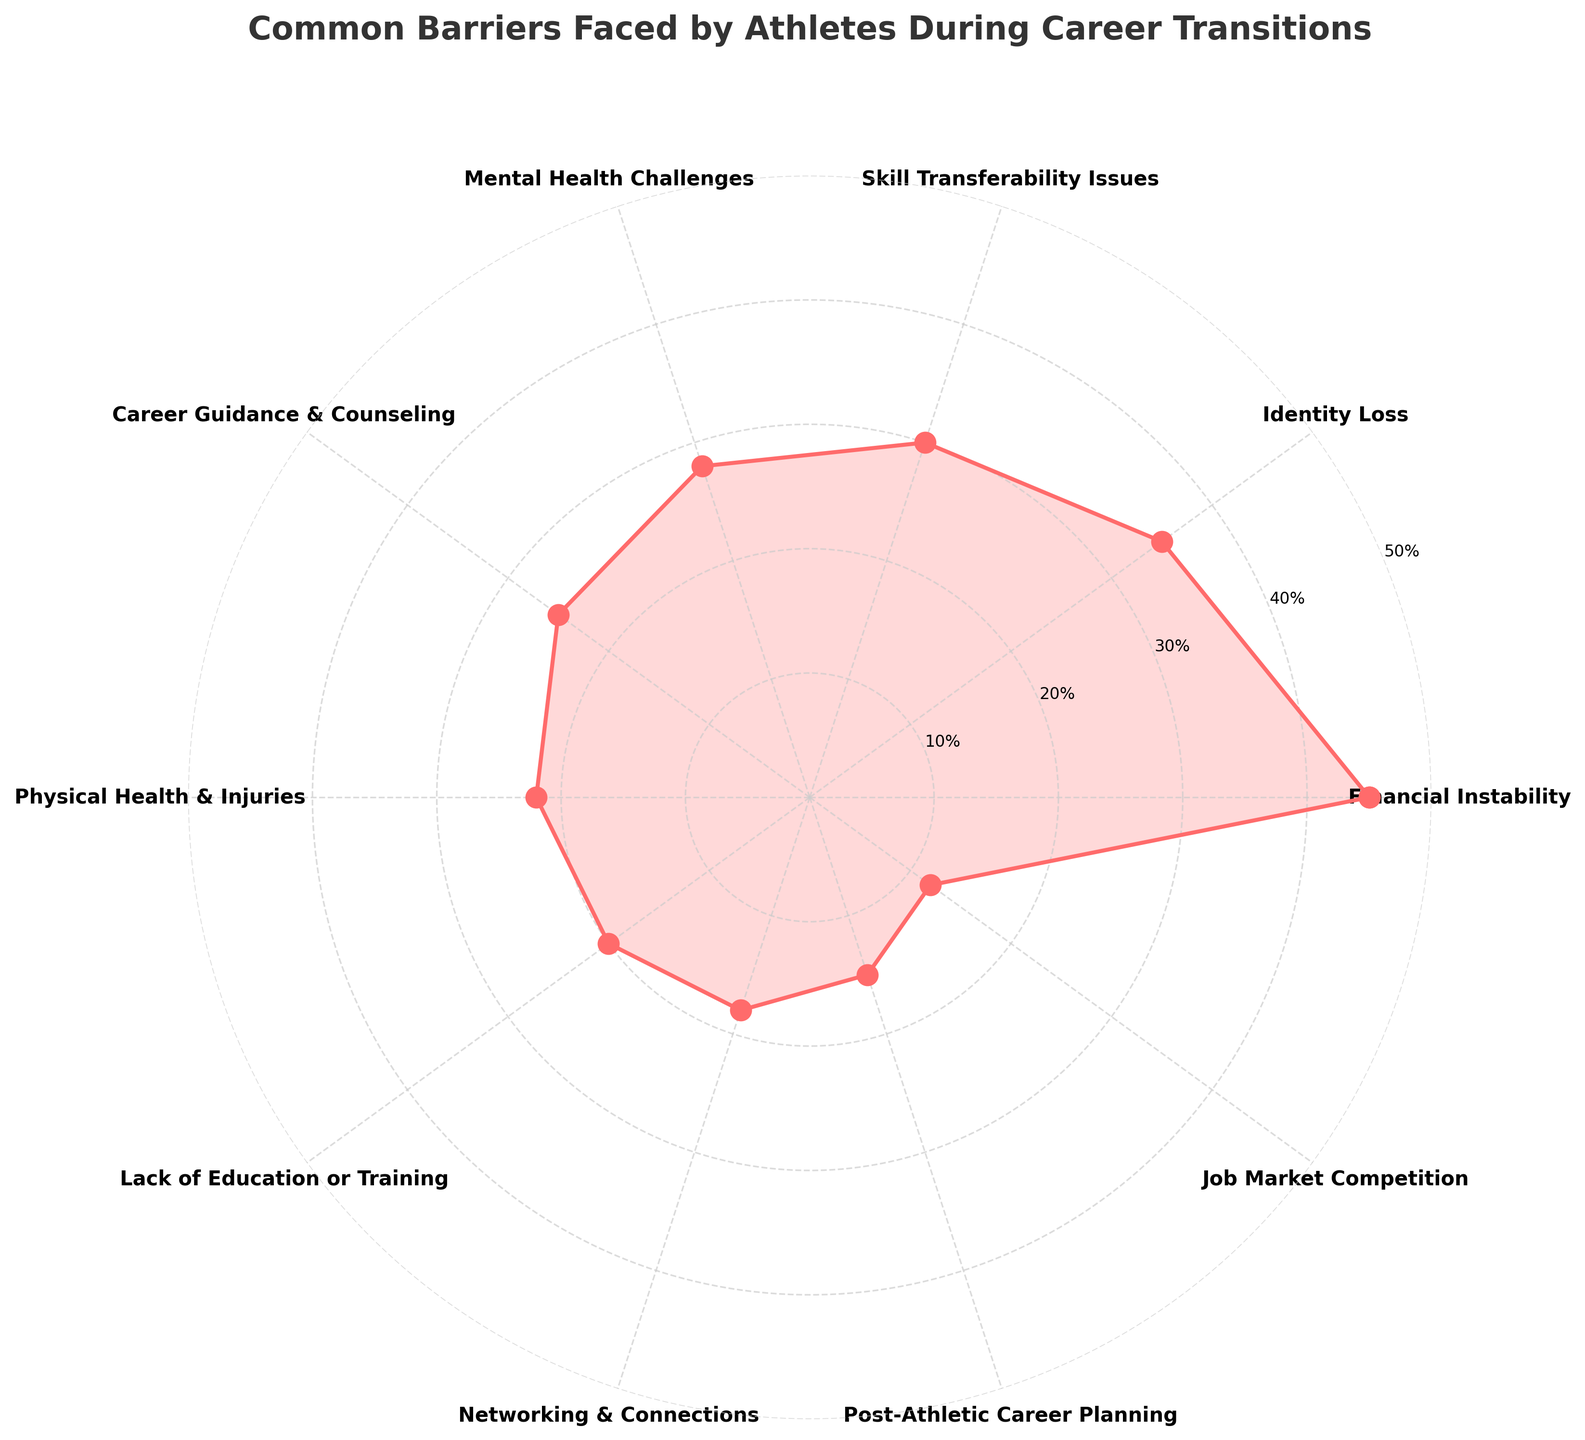what is the title of the polar chart? The title is typically the most prominent text on the plot, usually positioned at the top. In this case, it reads 'Common Barriers Faced by Athletes During Career Transitions.'
Answer: Common Barriers Faced by Athletes During Career Transitions How many barriers are shown on the chart? By counting the number of categories listed on the plot, we see that there are 10 unique barriers, starting from "Financial Instability" to "Job Market Competition."
Answer: 10 Which barrier has the highest frequency? By looking at the radial axis, the plot shows the highest point at "Financial Instability." This barrier has the highest frequency.
Answer: Financial Instability What is the frequency of "Skill Transferability Issues"? The frequency is indicated by the radial distance from the center for the label "Skill Transferability Issues." It is positioned at a distance that matches 30%.
Answer: 30% Compare "Identity Loss" and "Career Guidance & Counseling" in terms of frequency. Which one is higher and by how much? "Identity Loss" has a frequency of 35%, while "Career Guidance & Counseling" has a frequency of 25%. The difference in their frequencies is 35% - 25% = 10%.
Answer: Identity Loss is higher by 10% What two barriers have the closest frequency values? "Lack of Education or Training" and "Networking & Connections" are closest in frequency, with values of 20% and 18%, respectively. The difference between these is only 2%.
Answer: Lack of Education or Training and Networking & Connections What is the average frequency of all barriers? Sum all the frequencies given (45 + 35 + 30 + 28 + 25 + 22 + 20 + 18 + 15 + 12 = 250) and divide by the number of categories which is 10. Average frequency = 250 / 10 = 25%.
Answer: 25% Which barriers have a frequency less than 20%? From the plot, "Networking & Connections" (18%), "Post-Athletic Career Planning" (15%), and "Job Market Competition" (12%) have frequencies below 20%.
Answer: Networking & Connections, Post-Athletic Career Planning, and Job Market Competition What is the difference in frequency between the highest and the lowest barrier? The highest frequency is for "Financial Instability" at 45%, and the lowest is "Job Market Competition" at 12%. The difference is 45% - 12% = 33%.
Answer: 33% 